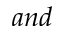<formula> <loc_0><loc_0><loc_500><loc_500>a n d</formula> 